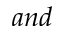<formula> <loc_0><loc_0><loc_500><loc_500>a n d</formula> 